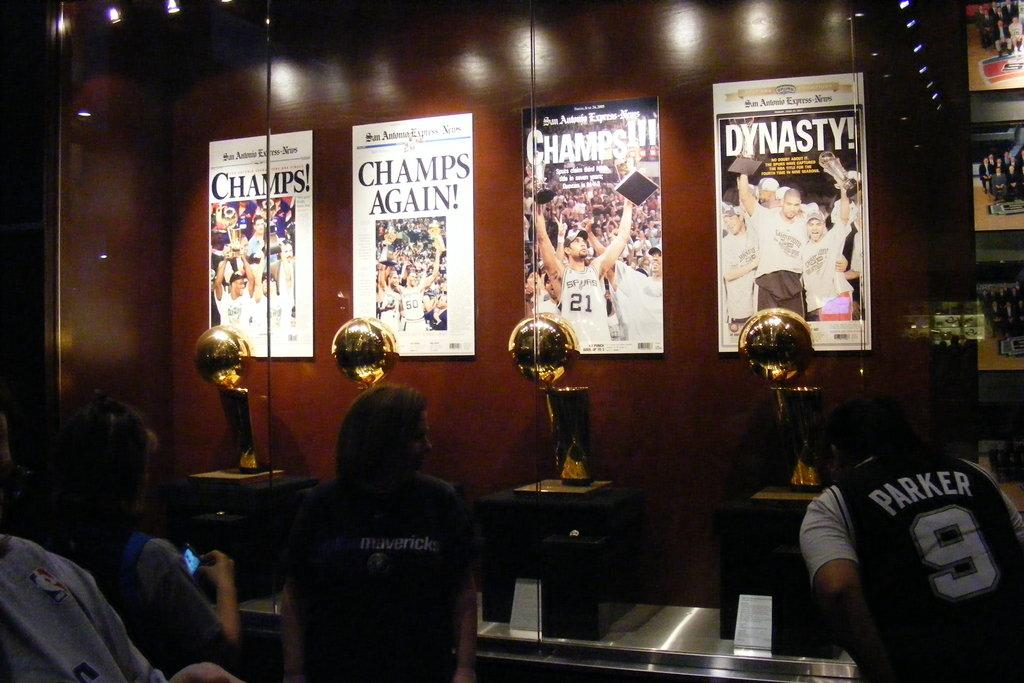Provide a one-sentence caption for the provided image. a few posters with one that says Dynasty on it. 